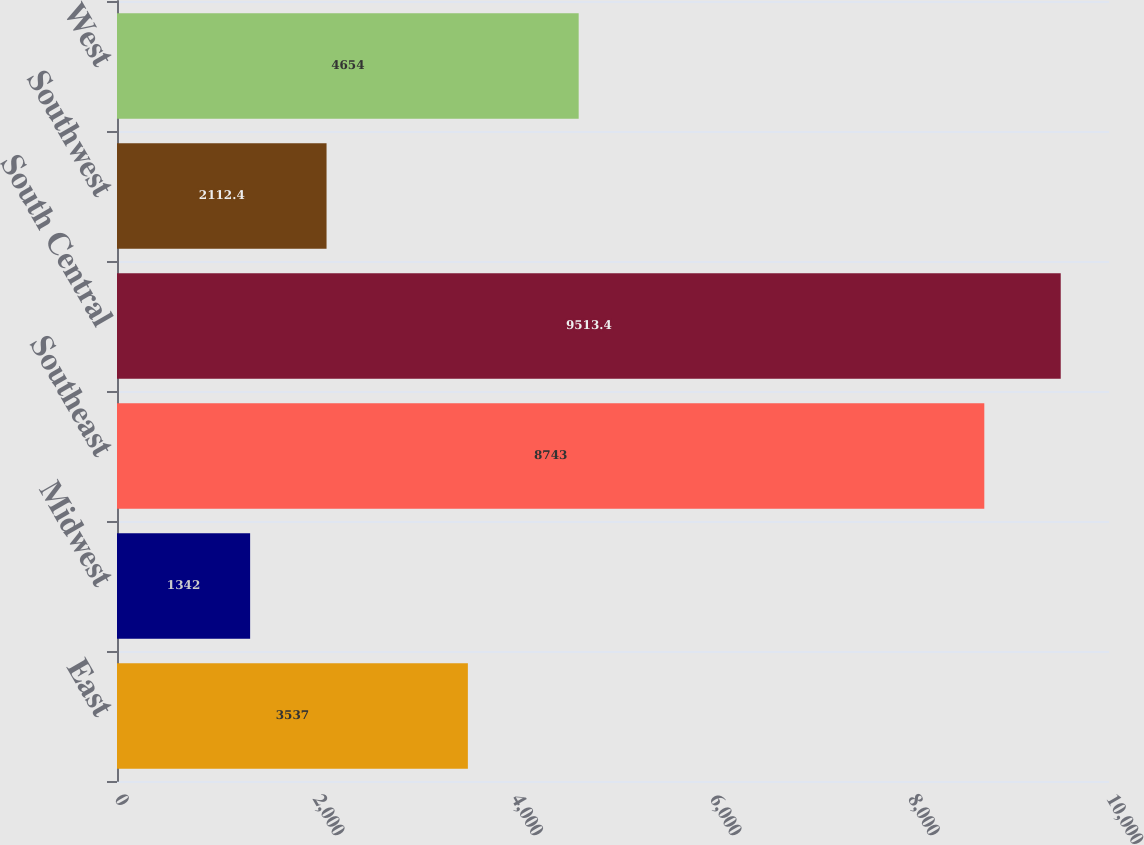<chart> <loc_0><loc_0><loc_500><loc_500><bar_chart><fcel>East<fcel>Midwest<fcel>Southeast<fcel>South Central<fcel>Southwest<fcel>West<nl><fcel>3537<fcel>1342<fcel>8743<fcel>9513.4<fcel>2112.4<fcel>4654<nl></chart> 